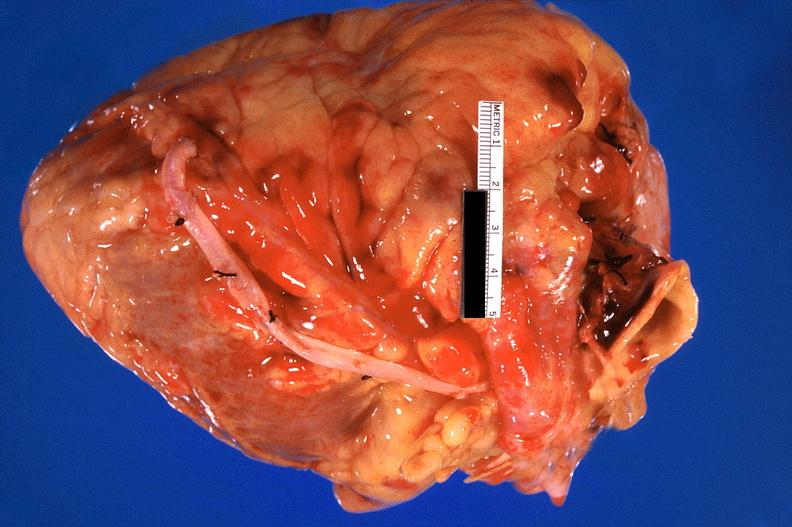where is this?
Answer the question using a single word or phrase. Heart 